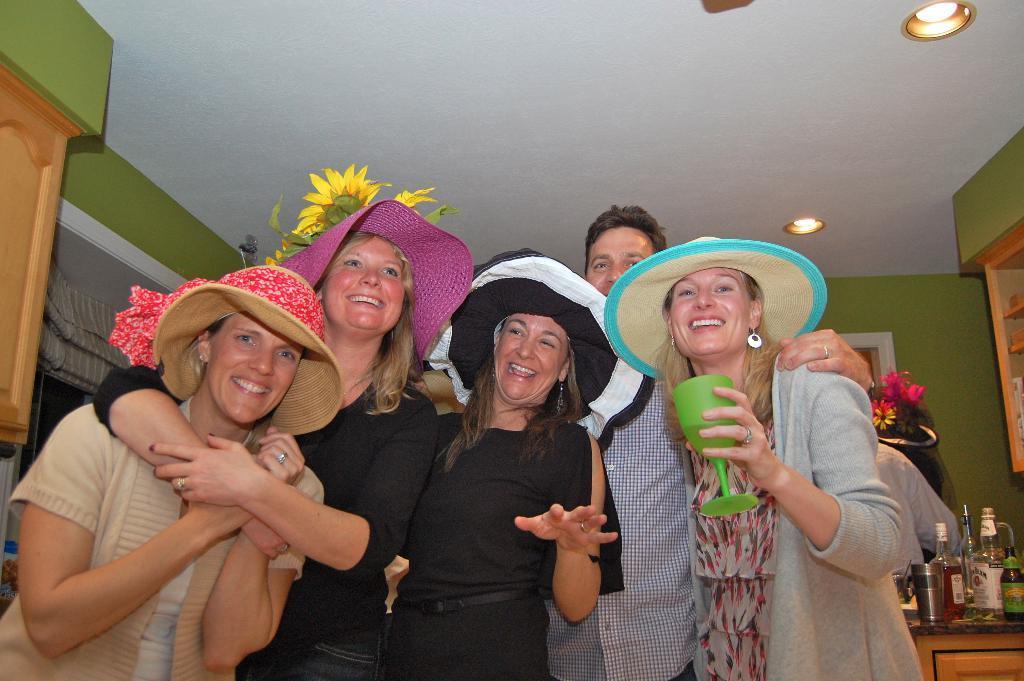Please provide a concise description of this image. In this image few persons are standing. Few persons are wearing hats. A woman wearing jacket is holding glass in his hand. Beside her there is a person standing. Right side there is a table having a glass and bottles on it. Few cupboards are attached to the roof. Top of the image there are few lights attached to the roof. 